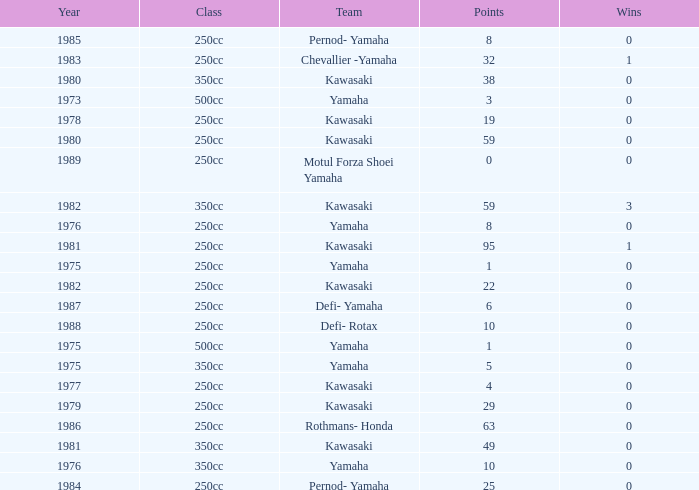How many points numbers had a class of 250cc, a year prior to 1978, Yamaha as a team, and where wins was more than 0? 0.0. 